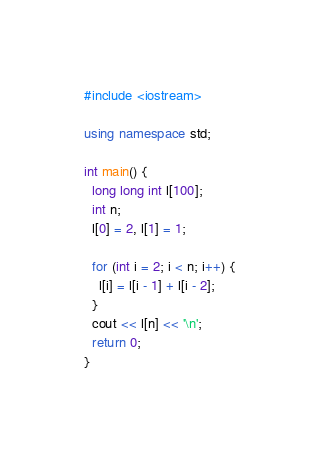<code> <loc_0><loc_0><loc_500><loc_500><_C++_>#include <iostream>

using namespace std;

int main() {
  long long int l[100];
  int n;
  l[0] = 2, l[1] = 1;

  for (int i = 2; i < n; i++) {
    l[i] = l[i - 1] + l[i - 2];
  }
  cout << l[n] << '\n';
  return 0;
}</code> 